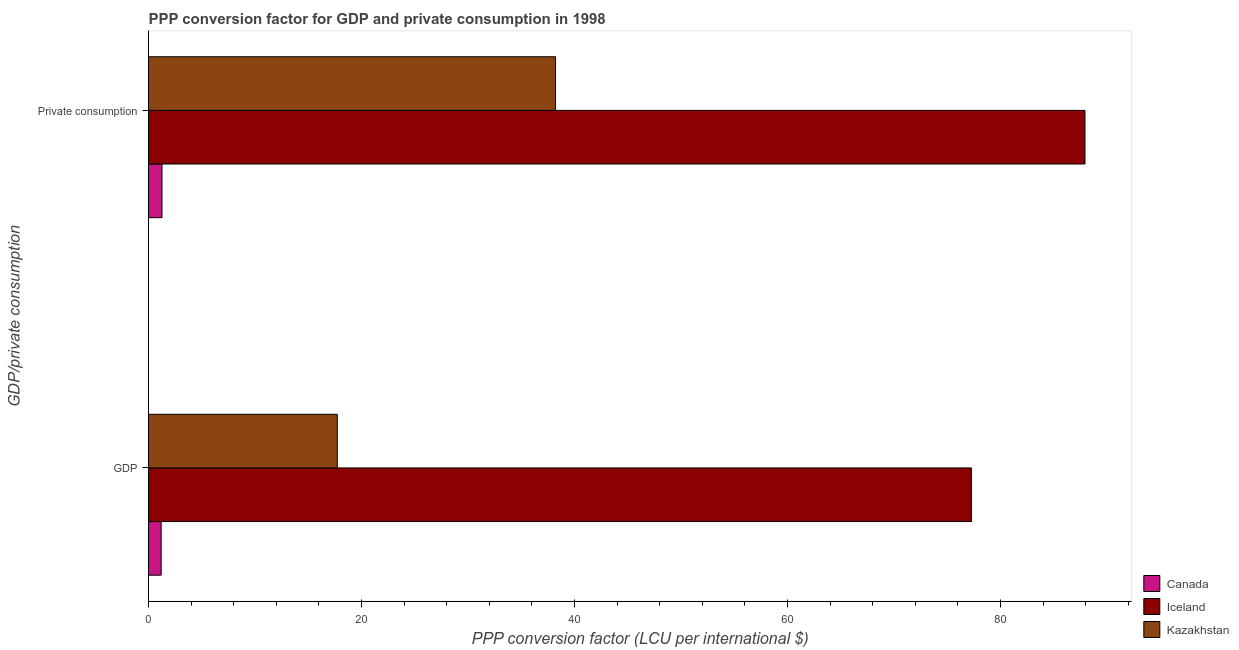How many groups of bars are there?
Your response must be concise. 2. Are the number of bars on each tick of the Y-axis equal?
Give a very brief answer. Yes. How many bars are there on the 2nd tick from the top?
Your response must be concise. 3. How many bars are there on the 2nd tick from the bottom?
Ensure brevity in your answer.  3. What is the label of the 2nd group of bars from the top?
Your answer should be compact. GDP. What is the ppp conversion factor for private consumption in Iceland?
Ensure brevity in your answer.  87.93. Across all countries, what is the maximum ppp conversion factor for private consumption?
Provide a succinct answer. 87.93. Across all countries, what is the minimum ppp conversion factor for private consumption?
Ensure brevity in your answer.  1.26. What is the total ppp conversion factor for gdp in the graph?
Your answer should be very brief. 96.18. What is the difference between the ppp conversion factor for gdp in Iceland and that in Kazakhstan?
Your answer should be very brief. 59.55. What is the difference between the ppp conversion factor for private consumption in Iceland and the ppp conversion factor for gdp in Kazakhstan?
Offer a terse response. 70.21. What is the average ppp conversion factor for gdp per country?
Your answer should be very brief. 32.06. What is the difference between the ppp conversion factor for private consumption and ppp conversion factor for gdp in Iceland?
Give a very brief answer. 10.66. What is the ratio of the ppp conversion factor for private consumption in Iceland to that in Canada?
Provide a short and direct response. 69.57. In how many countries, is the ppp conversion factor for gdp greater than the average ppp conversion factor for gdp taken over all countries?
Offer a very short reply. 1. What does the 1st bar from the top in  Private consumption represents?
Offer a terse response. Kazakhstan. Does the graph contain any zero values?
Ensure brevity in your answer.  No. What is the title of the graph?
Your answer should be very brief. PPP conversion factor for GDP and private consumption in 1998. Does "Bahamas" appear as one of the legend labels in the graph?
Keep it short and to the point. No. What is the label or title of the X-axis?
Ensure brevity in your answer.  PPP conversion factor (LCU per international $). What is the label or title of the Y-axis?
Offer a very short reply. GDP/private consumption. What is the PPP conversion factor (LCU per international $) of Canada in GDP?
Provide a succinct answer. 1.19. What is the PPP conversion factor (LCU per international $) of Iceland in GDP?
Offer a terse response. 77.27. What is the PPP conversion factor (LCU per international $) of Kazakhstan in GDP?
Provide a short and direct response. 17.72. What is the PPP conversion factor (LCU per international $) in Canada in  Private consumption?
Ensure brevity in your answer.  1.26. What is the PPP conversion factor (LCU per international $) in Iceland in  Private consumption?
Keep it short and to the point. 87.93. What is the PPP conversion factor (LCU per international $) of Kazakhstan in  Private consumption?
Your answer should be compact. 38.22. Across all GDP/private consumption, what is the maximum PPP conversion factor (LCU per international $) in Canada?
Give a very brief answer. 1.26. Across all GDP/private consumption, what is the maximum PPP conversion factor (LCU per international $) of Iceland?
Your response must be concise. 87.93. Across all GDP/private consumption, what is the maximum PPP conversion factor (LCU per international $) in Kazakhstan?
Your answer should be compact. 38.22. Across all GDP/private consumption, what is the minimum PPP conversion factor (LCU per international $) in Canada?
Make the answer very short. 1.19. Across all GDP/private consumption, what is the minimum PPP conversion factor (LCU per international $) in Iceland?
Offer a very short reply. 77.27. Across all GDP/private consumption, what is the minimum PPP conversion factor (LCU per international $) in Kazakhstan?
Keep it short and to the point. 17.72. What is the total PPP conversion factor (LCU per international $) in Canada in the graph?
Make the answer very short. 2.45. What is the total PPP conversion factor (LCU per international $) of Iceland in the graph?
Offer a very short reply. 165.2. What is the total PPP conversion factor (LCU per international $) in Kazakhstan in the graph?
Your answer should be compact. 55.94. What is the difference between the PPP conversion factor (LCU per international $) of Canada in GDP and that in  Private consumption?
Keep it short and to the point. -0.08. What is the difference between the PPP conversion factor (LCU per international $) in Iceland in GDP and that in  Private consumption?
Make the answer very short. -10.66. What is the difference between the PPP conversion factor (LCU per international $) of Kazakhstan in GDP and that in  Private consumption?
Make the answer very short. -20.49. What is the difference between the PPP conversion factor (LCU per international $) in Canada in GDP and the PPP conversion factor (LCU per international $) in Iceland in  Private consumption?
Your response must be concise. -86.74. What is the difference between the PPP conversion factor (LCU per international $) in Canada in GDP and the PPP conversion factor (LCU per international $) in Kazakhstan in  Private consumption?
Make the answer very short. -37.03. What is the difference between the PPP conversion factor (LCU per international $) in Iceland in GDP and the PPP conversion factor (LCU per international $) in Kazakhstan in  Private consumption?
Your answer should be very brief. 39.05. What is the average PPP conversion factor (LCU per international $) in Canada per GDP/private consumption?
Provide a short and direct response. 1.23. What is the average PPP conversion factor (LCU per international $) of Iceland per GDP/private consumption?
Your answer should be compact. 82.6. What is the average PPP conversion factor (LCU per international $) of Kazakhstan per GDP/private consumption?
Keep it short and to the point. 27.97. What is the difference between the PPP conversion factor (LCU per international $) in Canada and PPP conversion factor (LCU per international $) in Iceland in GDP?
Your answer should be very brief. -76.08. What is the difference between the PPP conversion factor (LCU per international $) of Canada and PPP conversion factor (LCU per international $) of Kazakhstan in GDP?
Provide a succinct answer. -16.54. What is the difference between the PPP conversion factor (LCU per international $) in Iceland and PPP conversion factor (LCU per international $) in Kazakhstan in GDP?
Offer a terse response. 59.55. What is the difference between the PPP conversion factor (LCU per international $) in Canada and PPP conversion factor (LCU per international $) in Iceland in  Private consumption?
Keep it short and to the point. -86.67. What is the difference between the PPP conversion factor (LCU per international $) of Canada and PPP conversion factor (LCU per international $) of Kazakhstan in  Private consumption?
Offer a very short reply. -36.95. What is the difference between the PPP conversion factor (LCU per international $) in Iceland and PPP conversion factor (LCU per international $) in Kazakhstan in  Private consumption?
Your response must be concise. 49.71. What is the ratio of the PPP conversion factor (LCU per international $) of Canada in GDP to that in  Private consumption?
Your response must be concise. 0.94. What is the ratio of the PPP conversion factor (LCU per international $) in Iceland in GDP to that in  Private consumption?
Provide a short and direct response. 0.88. What is the ratio of the PPP conversion factor (LCU per international $) in Kazakhstan in GDP to that in  Private consumption?
Offer a very short reply. 0.46. What is the difference between the highest and the second highest PPP conversion factor (LCU per international $) in Canada?
Keep it short and to the point. 0.08. What is the difference between the highest and the second highest PPP conversion factor (LCU per international $) in Iceland?
Your response must be concise. 10.66. What is the difference between the highest and the second highest PPP conversion factor (LCU per international $) of Kazakhstan?
Keep it short and to the point. 20.49. What is the difference between the highest and the lowest PPP conversion factor (LCU per international $) in Canada?
Provide a short and direct response. 0.08. What is the difference between the highest and the lowest PPP conversion factor (LCU per international $) of Iceland?
Give a very brief answer. 10.66. What is the difference between the highest and the lowest PPP conversion factor (LCU per international $) of Kazakhstan?
Your answer should be very brief. 20.49. 